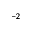<formula> <loc_0><loc_0><loc_500><loc_500>^ { - 2 }</formula> 